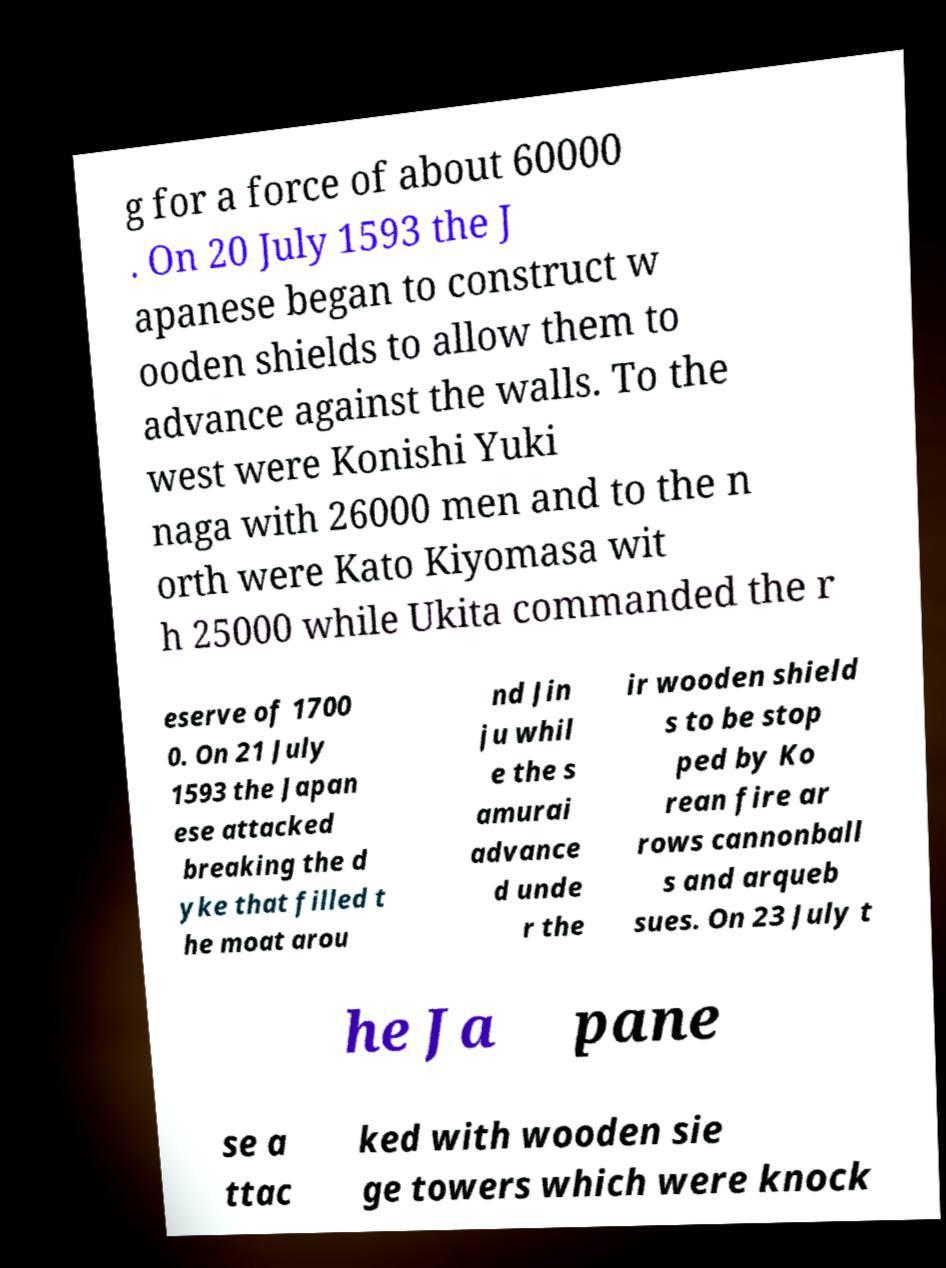What messages or text are displayed in this image? I need them in a readable, typed format. g for a force of about 60000 . On 20 July 1593 the J apanese began to construct w ooden shields to allow them to advance against the walls. To the west were Konishi Yuki naga with 26000 men and to the n orth were Kato Kiyomasa wit h 25000 while Ukita commanded the r eserve of 1700 0. On 21 July 1593 the Japan ese attacked breaking the d yke that filled t he moat arou nd Jin ju whil e the s amurai advance d unde r the ir wooden shield s to be stop ped by Ko rean fire ar rows cannonball s and arqueb sues. On 23 July t he Ja pane se a ttac ked with wooden sie ge towers which were knock 